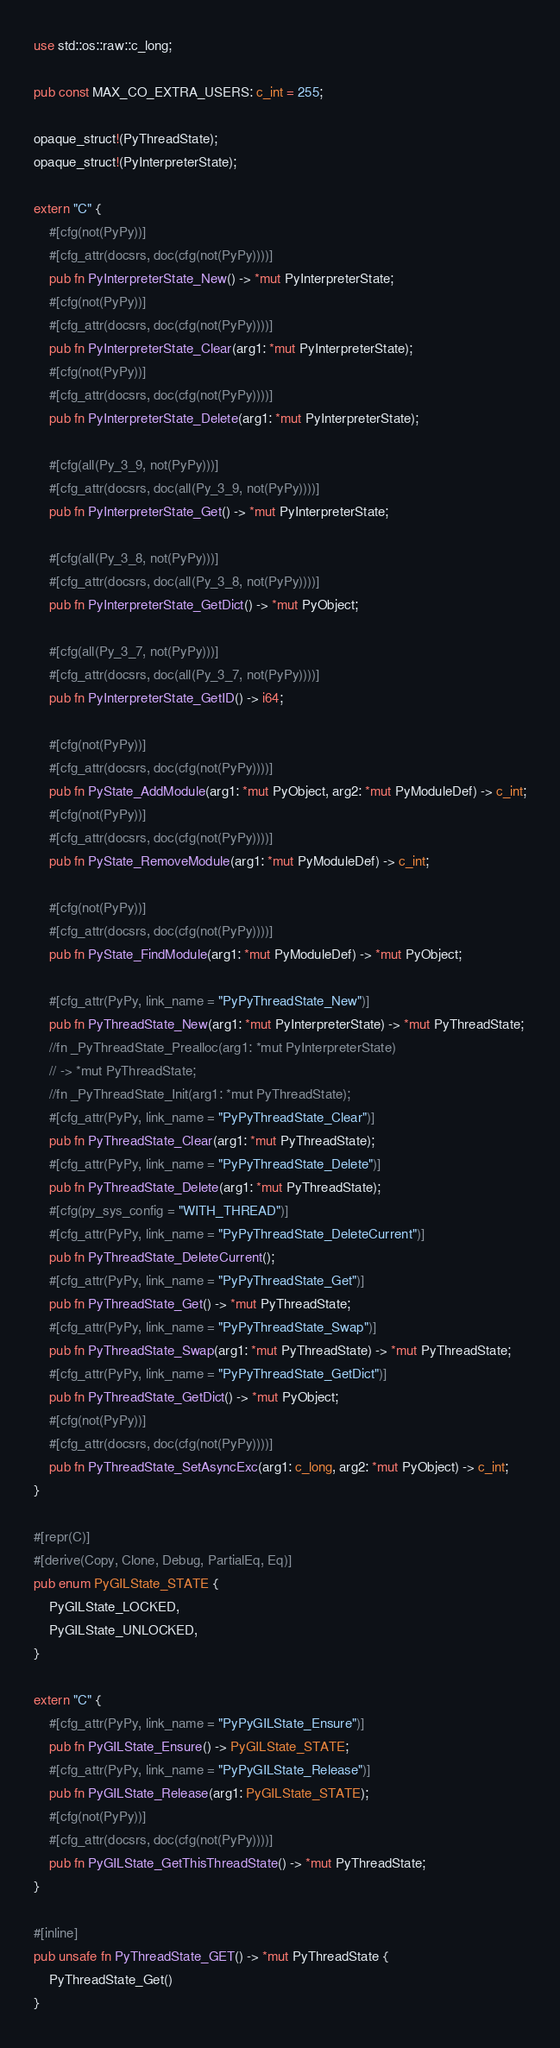<code> <loc_0><loc_0><loc_500><loc_500><_Rust_>use std::os::raw::c_long;

pub const MAX_CO_EXTRA_USERS: c_int = 255;

opaque_struct!(PyThreadState);
opaque_struct!(PyInterpreterState);

extern "C" {
    #[cfg(not(PyPy))]
    #[cfg_attr(docsrs, doc(cfg(not(PyPy))))]
    pub fn PyInterpreterState_New() -> *mut PyInterpreterState;
    #[cfg(not(PyPy))]
    #[cfg_attr(docsrs, doc(cfg(not(PyPy))))]
    pub fn PyInterpreterState_Clear(arg1: *mut PyInterpreterState);
    #[cfg(not(PyPy))]
    #[cfg_attr(docsrs, doc(cfg(not(PyPy))))]
    pub fn PyInterpreterState_Delete(arg1: *mut PyInterpreterState);

    #[cfg(all(Py_3_9, not(PyPy)))]
    #[cfg_attr(docsrs, doc(all(Py_3_9, not(PyPy))))]
    pub fn PyInterpreterState_Get() -> *mut PyInterpreterState;

    #[cfg(all(Py_3_8, not(PyPy)))]
    #[cfg_attr(docsrs, doc(all(Py_3_8, not(PyPy))))]
    pub fn PyInterpreterState_GetDict() -> *mut PyObject;

    #[cfg(all(Py_3_7, not(PyPy)))]
    #[cfg_attr(docsrs, doc(all(Py_3_7, not(PyPy))))]
    pub fn PyInterpreterState_GetID() -> i64;

    #[cfg(not(PyPy))]
    #[cfg_attr(docsrs, doc(cfg(not(PyPy))))]
    pub fn PyState_AddModule(arg1: *mut PyObject, arg2: *mut PyModuleDef) -> c_int;
    #[cfg(not(PyPy))]
    #[cfg_attr(docsrs, doc(cfg(not(PyPy))))]
    pub fn PyState_RemoveModule(arg1: *mut PyModuleDef) -> c_int;

    #[cfg(not(PyPy))]
    #[cfg_attr(docsrs, doc(cfg(not(PyPy))))]
    pub fn PyState_FindModule(arg1: *mut PyModuleDef) -> *mut PyObject;

    #[cfg_attr(PyPy, link_name = "PyPyThreadState_New")]
    pub fn PyThreadState_New(arg1: *mut PyInterpreterState) -> *mut PyThreadState;
    //fn _PyThreadState_Prealloc(arg1: *mut PyInterpreterState)
    // -> *mut PyThreadState;
    //fn _PyThreadState_Init(arg1: *mut PyThreadState);
    #[cfg_attr(PyPy, link_name = "PyPyThreadState_Clear")]
    pub fn PyThreadState_Clear(arg1: *mut PyThreadState);
    #[cfg_attr(PyPy, link_name = "PyPyThreadState_Delete")]
    pub fn PyThreadState_Delete(arg1: *mut PyThreadState);
    #[cfg(py_sys_config = "WITH_THREAD")]
    #[cfg_attr(PyPy, link_name = "PyPyThreadState_DeleteCurrent")]
    pub fn PyThreadState_DeleteCurrent();
    #[cfg_attr(PyPy, link_name = "PyPyThreadState_Get")]
    pub fn PyThreadState_Get() -> *mut PyThreadState;
    #[cfg_attr(PyPy, link_name = "PyPyThreadState_Swap")]
    pub fn PyThreadState_Swap(arg1: *mut PyThreadState) -> *mut PyThreadState;
    #[cfg_attr(PyPy, link_name = "PyPyThreadState_GetDict")]
    pub fn PyThreadState_GetDict() -> *mut PyObject;
    #[cfg(not(PyPy))]
    #[cfg_attr(docsrs, doc(cfg(not(PyPy))))]
    pub fn PyThreadState_SetAsyncExc(arg1: c_long, arg2: *mut PyObject) -> c_int;
}

#[repr(C)]
#[derive(Copy, Clone, Debug, PartialEq, Eq)]
pub enum PyGILState_STATE {
    PyGILState_LOCKED,
    PyGILState_UNLOCKED,
}

extern "C" {
    #[cfg_attr(PyPy, link_name = "PyPyGILState_Ensure")]
    pub fn PyGILState_Ensure() -> PyGILState_STATE;
    #[cfg_attr(PyPy, link_name = "PyPyGILState_Release")]
    pub fn PyGILState_Release(arg1: PyGILState_STATE);
    #[cfg(not(PyPy))]
    #[cfg_attr(docsrs, doc(cfg(not(PyPy))))]
    pub fn PyGILState_GetThisThreadState() -> *mut PyThreadState;
}

#[inline]
pub unsafe fn PyThreadState_GET() -> *mut PyThreadState {
    PyThreadState_Get()
}
</code> 